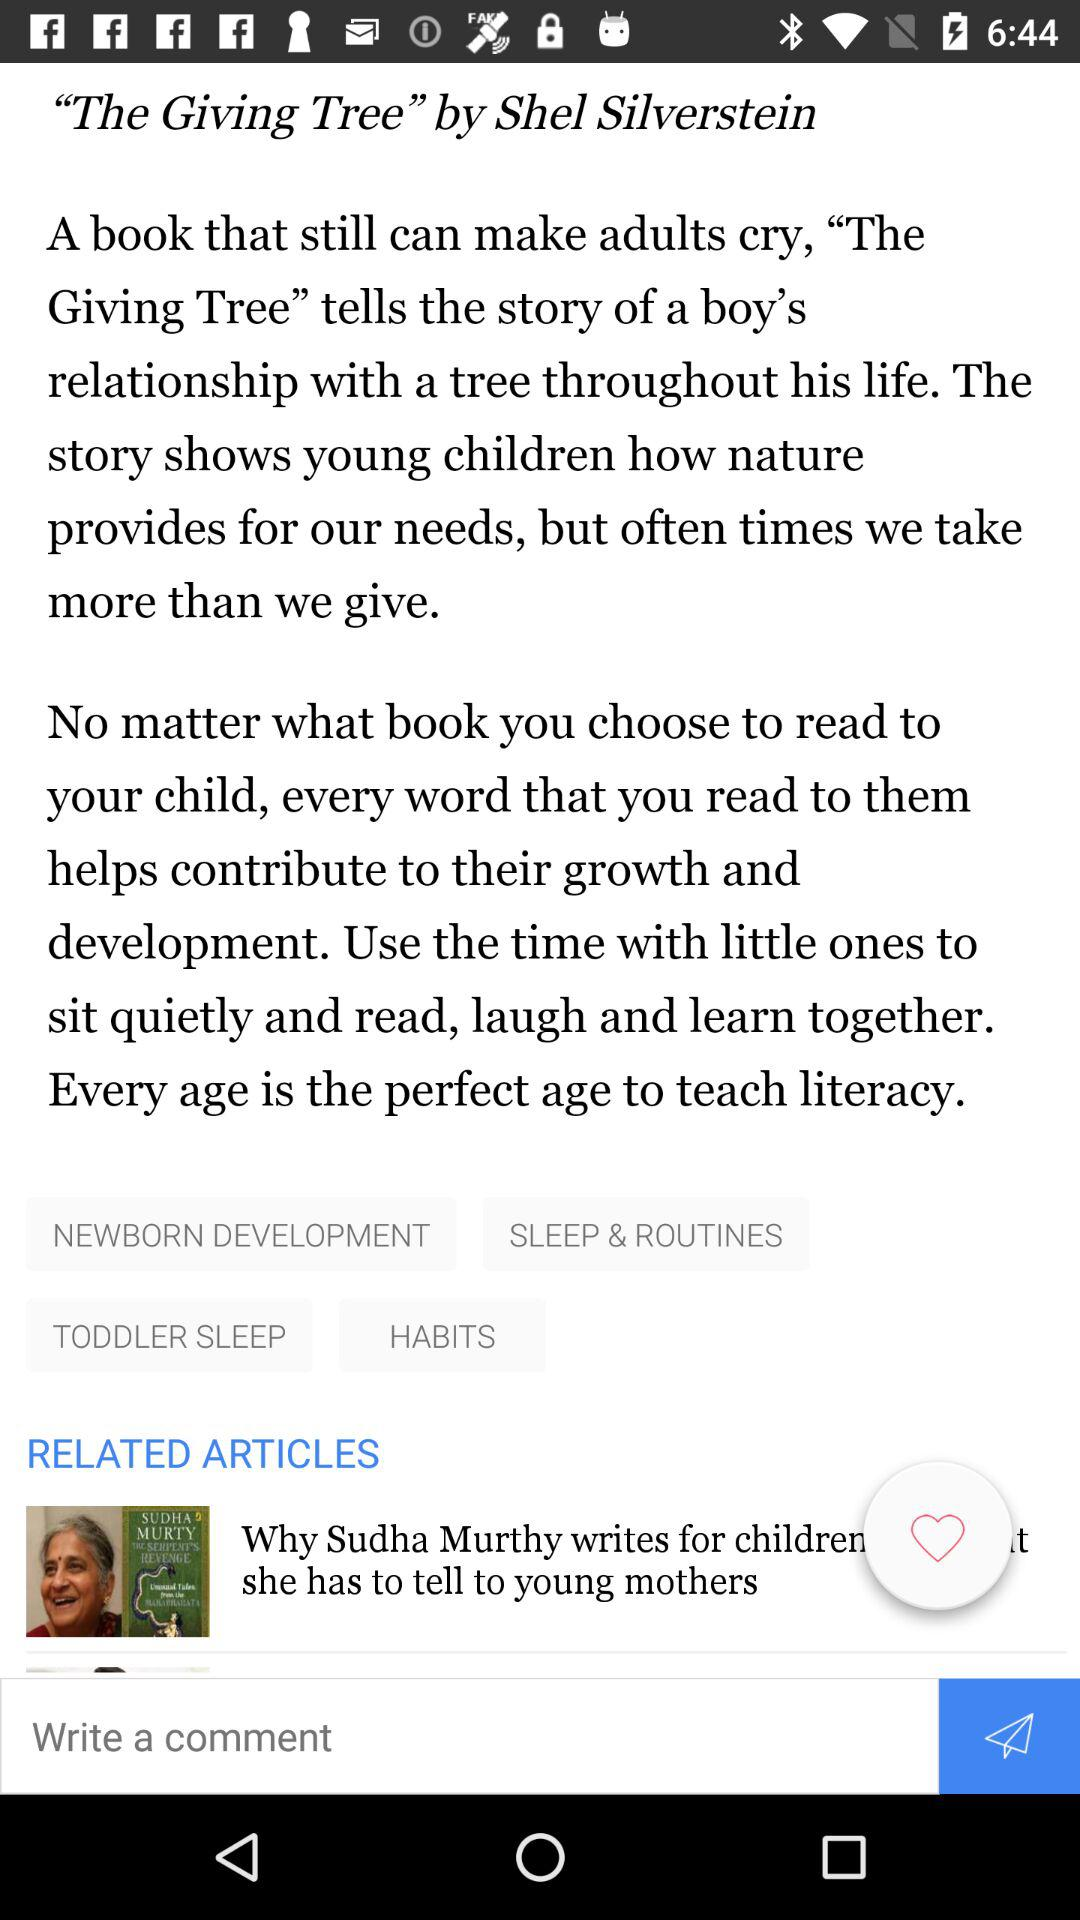What's the title of the article? The title of the article is "The Giving Tree". 